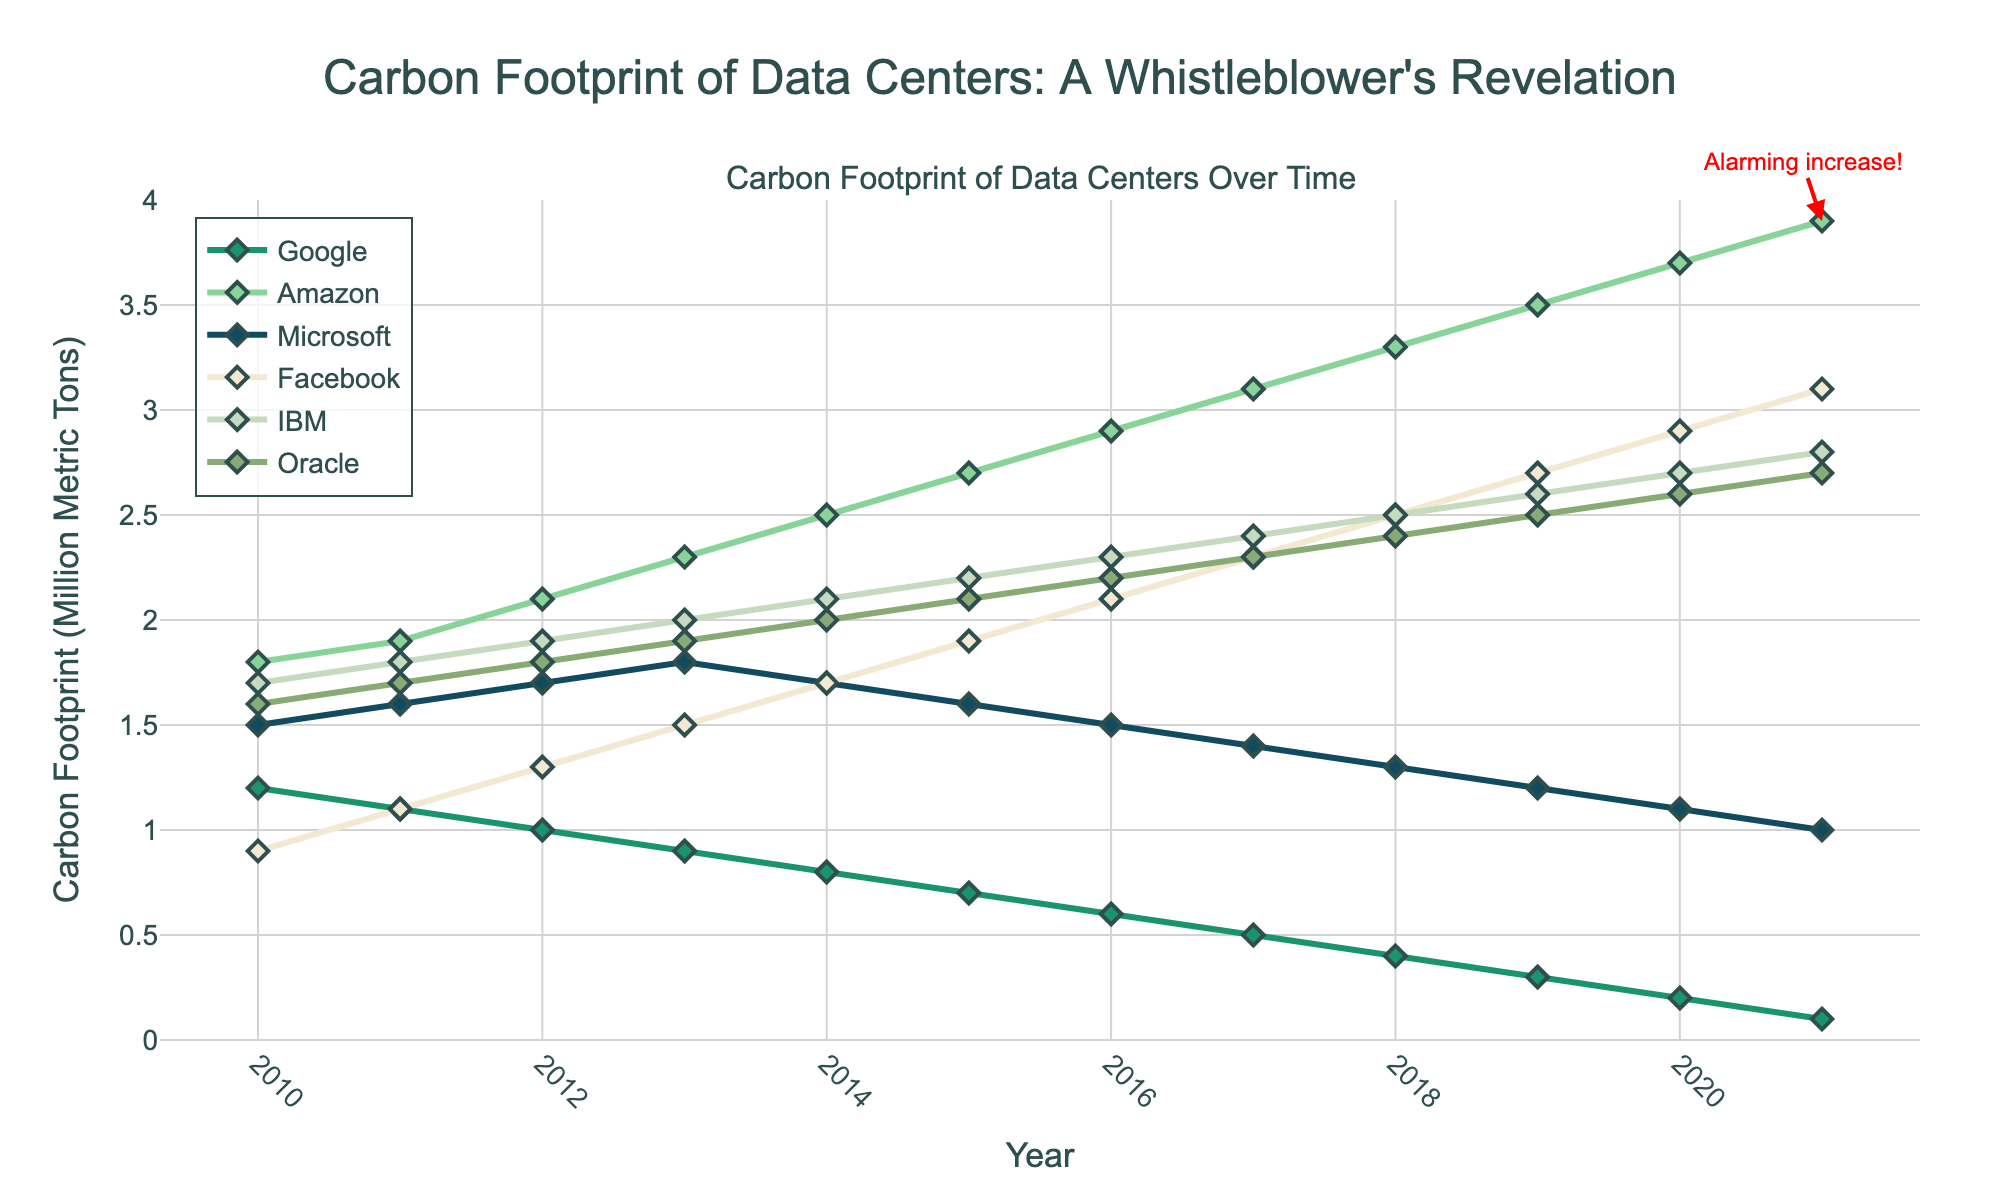What's the general trend of Google's carbon footprint from 2010 to 2021? Over the years, Google's carbon footprint shows a consistent decrease from 1.2 million metric tons in 2010 to 0.1 million metric tons in 2021. The line for Google on the plot slopes downward over time.
Answer: Decrease Which company's carbon footprint shows the most significant increase between 2010 and 2021? By observing the slopes of the lines, Amazon's carbon footprint shows the steepest increase, going from 1.8 million metric tons in 2010 to 3.9 million metric tons in 2021, which is a clear visual indicator of rapid growth.
Answer: Amazon What is the difference in carbon footprint between Amazon and Microsoft in 2021? Check the y-values for Amazon and Microsoft in 2021. Amazon is at 3.9 million metric tons, and Microsoft is at 1.0 million metric tons. The difference is 3.9 - 1.0 = 2.9.
Answer: 2.9 million metric tons Which company had the lowest carbon footprint in 2010 and 2021 respectively? In 2010, Facebook had the lowest footprint at 0.9 million metric tons. In 2021, Google had the lowest at 0.1 million metric tons.
Answer: Facebook (2010), Google (2021) How does IBM's carbon footprint change from 2015 to 2020? IBM's carbon footprint increases from 2.2 million metric tons in 2015 to 2.7 million metric tons in 2020. The line for IBM slopes slightly upward during these years.
Answer: Increase Compare the carbon footprints of companies with green initiatives versus without (based on visual inspection). Observing the colors and trends: Google, Microsoft, and Facebook (green initiative companies) generally show a downward or more stable trend, whereas Amazon, IBM, and Oracle (without green initiatives) show a continuous increase in their carbon footprints.
Answer: Companies with green initiatives show a decrease, others show an increase What is the average carbon footprint of Facebook from 2010 to 2021? Calculate the average by summing Facebook's footprints over the 12 years: (0.9+1.1+1.3+1.5+1.7+1.9+2.1+2.3+2.5+2.7+2.9+3.1) = 24.0. Then, divide by the number of years: 24.0 / 12 = 2.
Answer: 2 million metric tons Which year does the carbon footprint of Oracle first exceed 2.0 million metric tons? By following Oracle's line in the plot, it first exceeds 2.0 million metric tons between 2014 and 2015. Specifically, it is during the year 2014.
Answer: 2014 